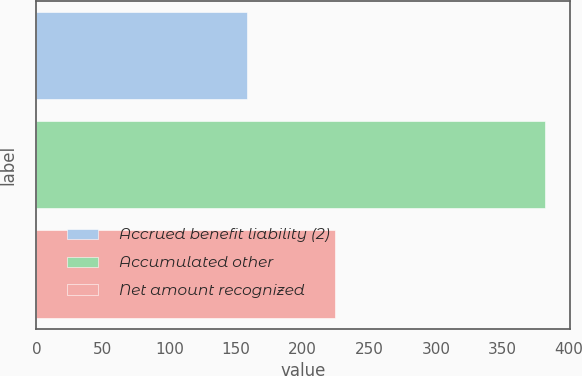Convert chart. <chart><loc_0><loc_0><loc_500><loc_500><bar_chart><fcel>Accrued benefit liability (2)<fcel>Accumulated other<fcel>Net amount recognized<nl><fcel>158<fcel>382<fcel>224<nl></chart> 